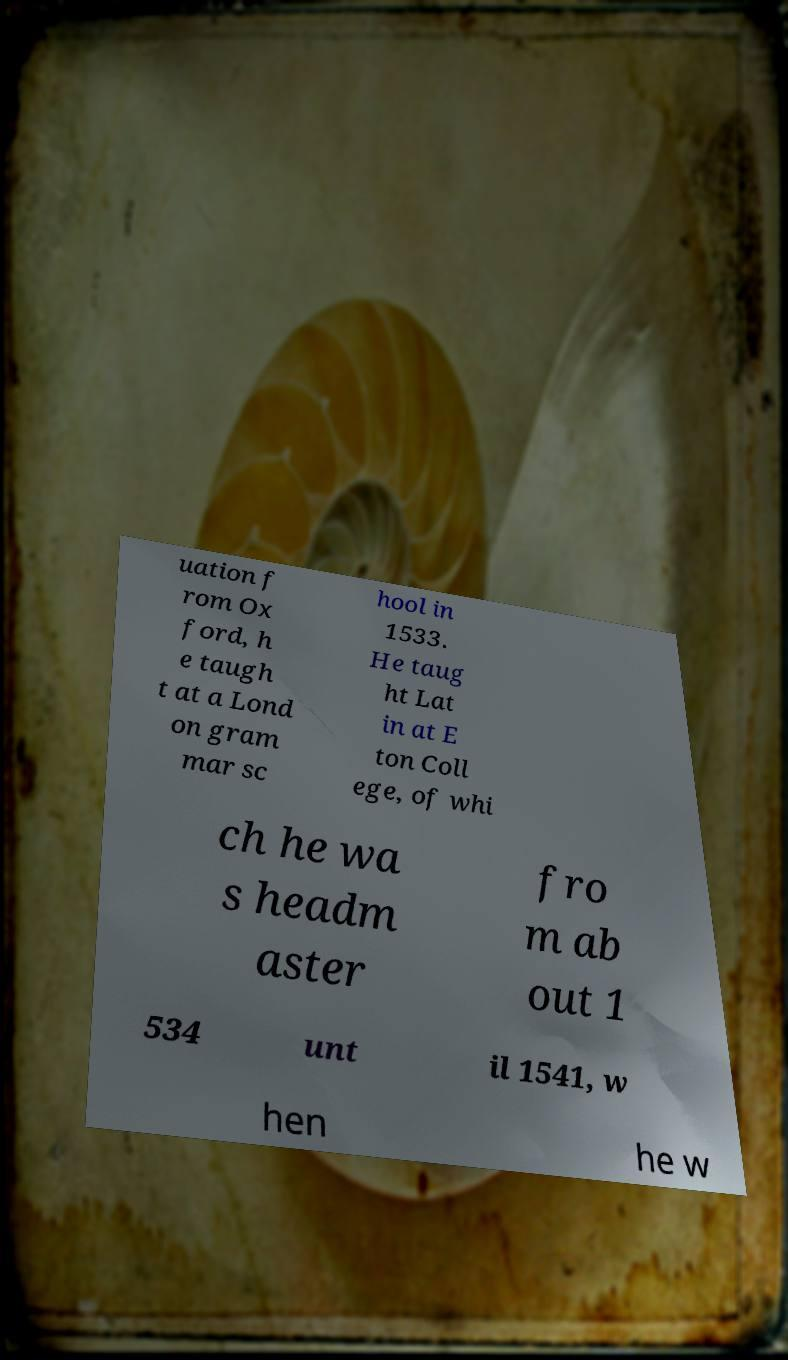Could you extract and type out the text from this image? uation f rom Ox ford, h e taugh t at a Lond on gram mar sc hool in 1533. He taug ht Lat in at E ton Coll ege, of whi ch he wa s headm aster fro m ab out 1 534 unt il 1541, w hen he w 